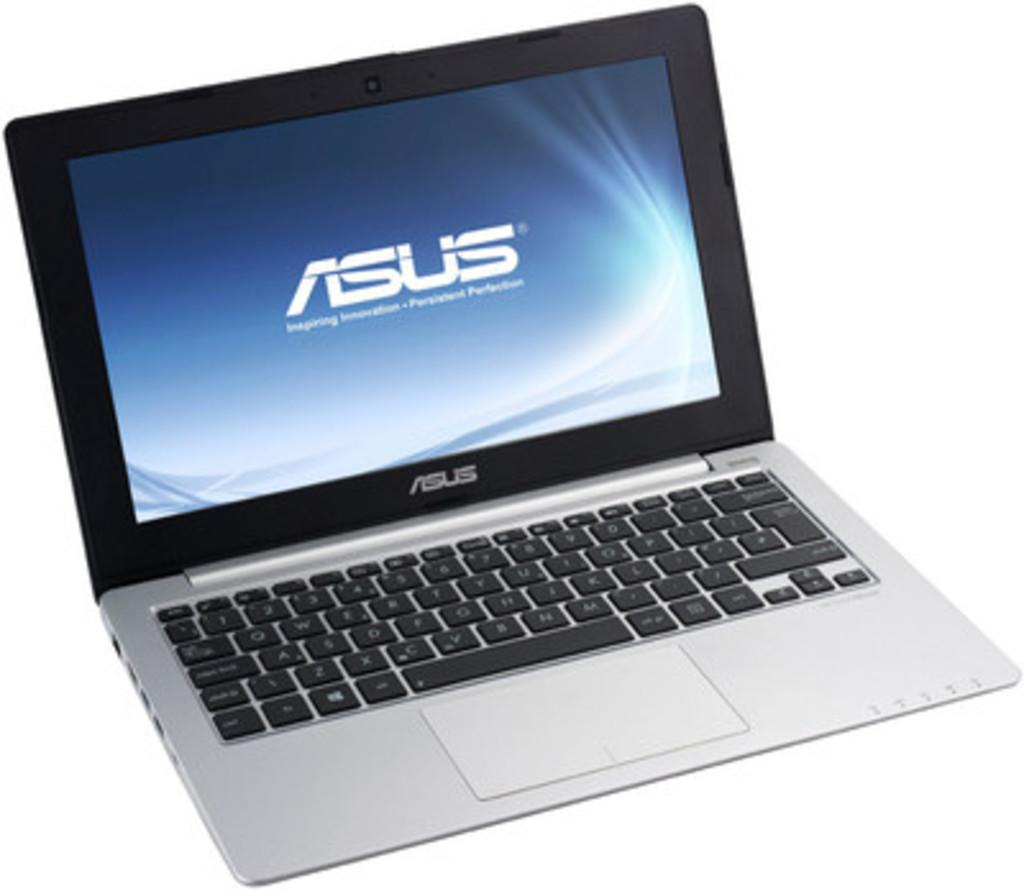<image>
Present a compact description of the photo's key features. An open laptop displays the ASUS logo on a blue screen. 